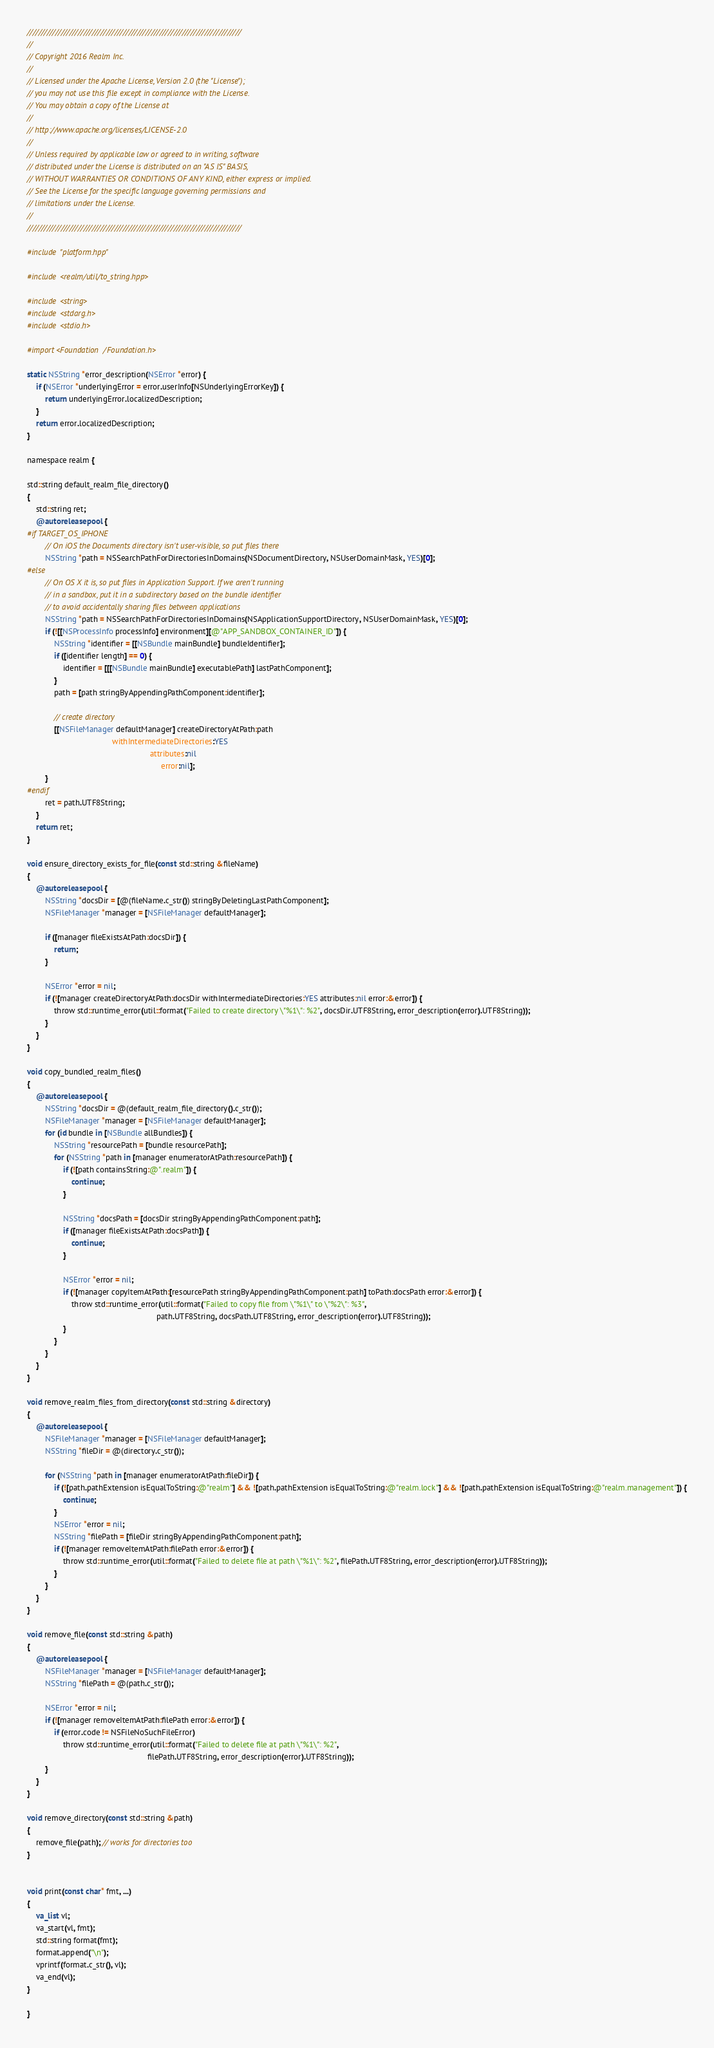Convert code to text. <code><loc_0><loc_0><loc_500><loc_500><_ObjectiveC_>////////////////////////////////////////////////////////////////////////////
//
// Copyright 2016 Realm Inc.
//
// Licensed under the Apache License, Version 2.0 (the "License");
// you may not use this file except in compliance with the License.
// You may obtain a copy of the License at
//
// http://www.apache.org/licenses/LICENSE-2.0
//
// Unless required by applicable law or agreed to in writing, software
// distributed under the License is distributed on an "AS IS" BASIS,
// WITHOUT WARRANTIES OR CONDITIONS OF ANY KIND, either express or implied.
// See the License for the specific language governing permissions and
// limitations under the License.
//
////////////////////////////////////////////////////////////////////////////

#include "platform.hpp"

#include <realm/util/to_string.hpp>

#include <string>
#include <stdarg.h>
#include <stdio.h>

#import <Foundation/Foundation.h>

static NSString *error_description(NSError *error) {
    if (NSError *underlyingError = error.userInfo[NSUnderlyingErrorKey]) {
        return underlyingError.localizedDescription;
    }
    return error.localizedDescription;
}

namespace realm {

std::string default_realm_file_directory()
{
    std::string ret;
    @autoreleasepool {
#if TARGET_OS_IPHONE
        // On iOS the Documents directory isn't user-visible, so put files there
        NSString *path = NSSearchPathForDirectoriesInDomains(NSDocumentDirectory, NSUserDomainMask, YES)[0];
#else
        // On OS X it is, so put files in Application Support. If we aren't running
        // in a sandbox, put it in a subdirectory based on the bundle identifier
        // to avoid accidentally sharing files between applications
        NSString *path = NSSearchPathForDirectoriesInDomains(NSApplicationSupportDirectory, NSUserDomainMask, YES)[0];
        if (![[NSProcessInfo processInfo] environment][@"APP_SANDBOX_CONTAINER_ID"]) {
            NSString *identifier = [[NSBundle mainBundle] bundleIdentifier];
            if ([identifier length] == 0) {
                identifier = [[[NSBundle mainBundle] executablePath] lastPathComponent];
            }
            path = [path stringByAppendingPathComponent:identifier];

            // create directory
            [[NSFileManager defaultManager] createDirectoryAtPath:path
                                      withIntermediateDirectories:YES
                                                       attributes:nil
                                                            error:nil];
        }
#endif
        ret = path.UTF8String;
    }
    return ret;
}

void ensure_directory_exists_for_file(const std::string &fileName)
{
    @autoreleasepool {
        NSString *docsDir = [@(fileName.c_str()) stringByDeletingLastPathComponent];
        NSFileManager *manager = [NSFileManager defaultManager];

        if ([manager fileExistsAtPath:docsDir]) {
            return;
        }

        NSError *error = nil;
        if (![manager createDirectoryAtPath:docsDir withIntermediateDirectories:YES attributes:nil error:&error]) {
            throw std::runtime_error(util::format("Failed to create directory \"%1\": %2", docsDir.UTF8String, error_description(error).UTF8String));
        }
    }
}

void copy_bundled_realm_files()
{
    @autoreleasepool {
        NSString *docsDir = @(default_realm_file_directory().c_str());
        NSFileManager *manager = [NSFileManager defaultManager];
        for (id bundle in [NSBundle allBundles]) {
            NSString *resourcePath = [bundle resourcePath];
            for (NSString *path in [manager enumeratorAtPath:resourcePath]) {
                if (![path containsString:@".realm"]) {
                    continue;
                }

                NSString *docsPath = [docsDir stringByAppendingPathComponent:path];
                if ([manager fileExistsAtPath:docsPath]) {
                    continue;
                }

                NSError *error = nil;
                if (![manager copyItemAtPath:[resourcePath stringByAppendingPathComponent:path] toPath:docsPath error:&error]) {
                    throw std::runtime_error(util::format("Failed to copy file from \"%1\" to \"%2\": %3",
                                                          path.UTF8String, docsPath.UTF8String, error_description(error).UTF8String));
                }
            }
        }
    }
}
    
void remove_realm_files_from_directory(const std::string &directory)
{
    @autoreleasepool {
        NSFileManager *manager = [NSFileManager defaultManager];
        NSString *fileDir = @(directory.c_str());

        for (NSString *path in [manager enumeratorAtPath:fileDir]) {
            if (![path.pathExtension isEqualToString:@"realm"] && ![path.pathExtension isEqualToString:@"realm.lock"] && ![path.pathExtension isEqualToString:@"realm.management"]) {
                continue;
            }
            NSError *error = nil;
            NSString *filePath = [fileDir stringByAppendingPathComponent:path];
            if (![manager removeItemAtPath:filePath error:&error]) {
                throw std::runtime_error(util::format("Failed to delete file at path \"%1\": %2", filePath.UTF8String, error_description(error).UTF8String));
            }
        }
    }
}

void remove_file(const std::string &path)
{
    @autoreleasepool {
        NSFileManager *manager = [NSFileManager defaultManager];
        NSString *filePath = @(path.c_str());

        NSError *error = nil;
        if (![manager removeItemAtPath:filePath error:&error]) {
            if (error.code != NSFileNoSuchFileError)
                throw std::runtime_error(util::format("Failed to delete file at path \"%1\": %2",
                                                      filePath.UTF8String, error_description(error).UTF8String));
        }
    }
}

void remove_directory(const std::string &path)
{
    remove_file(path); // works for directories too
}


void print(const char* fmt, ...)
{
    va_list vl;
    va_start(vl, fmt);
    std::string format(fmt);
    format.append("\n");
    vprintf(format.c_str(), vl);
    va_end(vl);
}

}
</code> 